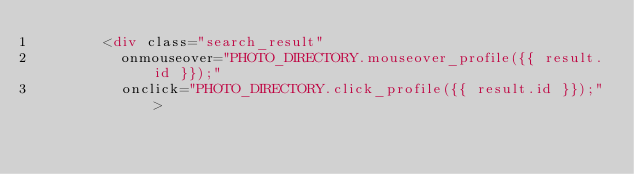<code> <loc_0><loc_0><loc_500><loc_500><_HTML_>        <div class="search_result"
          onmouseover="PHOTO_DIRECTORY.mouseover_profile({{ result.id }});"
          onclick="PHOTO_DIRECTORY.click_profile({{ result.id }});">
</code> 